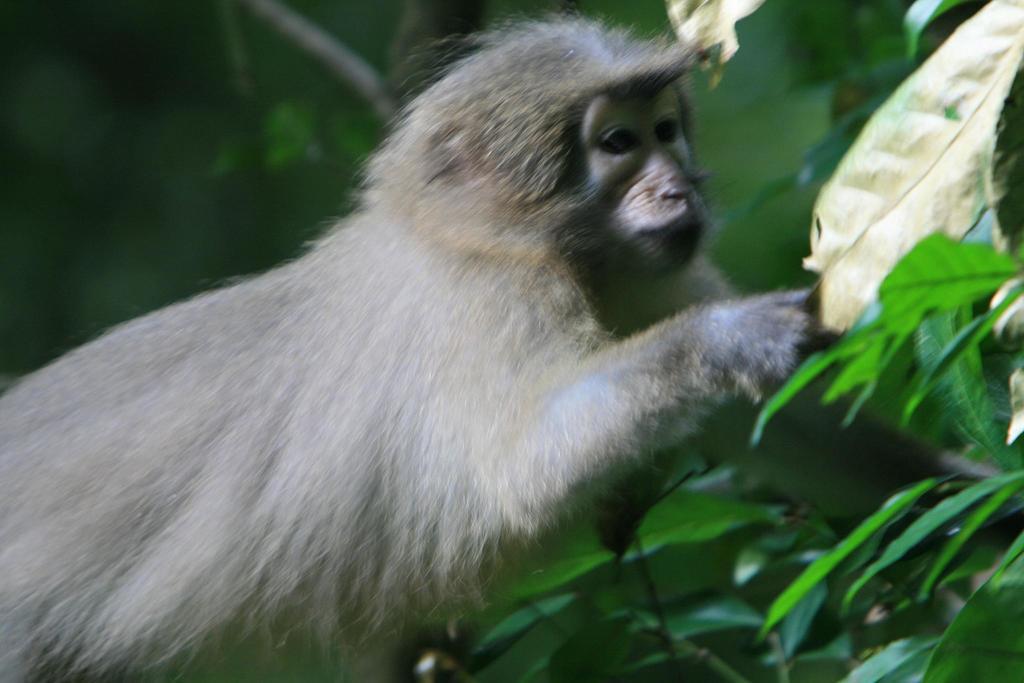How would you summarize this image in a sentence or two? In this image, I can see a monkey and the leaves. The background is blurry. 